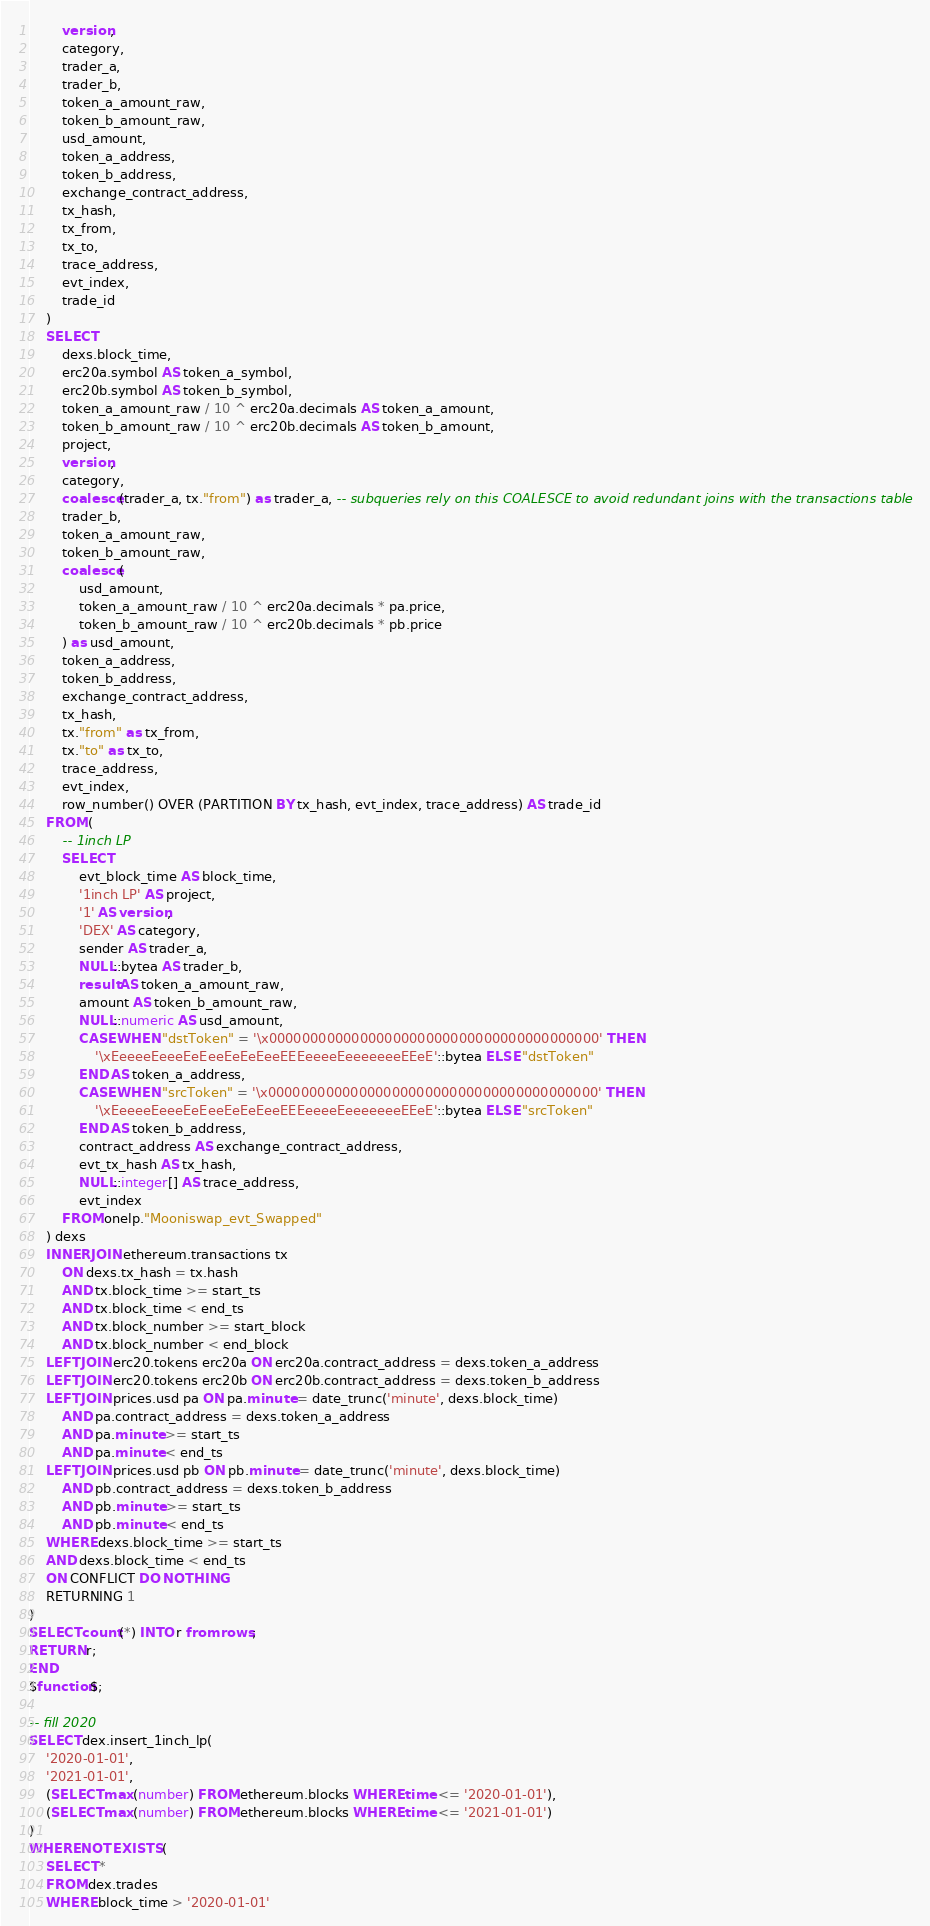<code> <loc_0><loc_0><loc_500><loc_500><_SQL_>        version,
        category,
        trader_a,
        trader_b,
        token_a_amount_raw,
        token_b_amount_raw,
        usd_amount,
        token_a_address,
        token_b_address,
        exchange_contract_address,
        tx_hash,
        tx_from,
        tx_to,
        trace_address,
        evt_index,
        trade_id
    )
    SELECT
        dexs.block_time,
        erc20a.symbol AS token_a_symbol,
        erc20b.symbol AS token_b_symbol,
        token_a_amount_raw / 10 ^ erc20a.decimals AS token_a_amount,
        token_b_amount_raw / 10 ^ erc20b.decimals AS token_b_amount,
        project,
        version,
        category,
        coalesce(trader_a, tx."from") as trader_a, -- subqueries rely on this COALESCE to avoid redundant joins with the transactions table
        trader_b,
        token_a_amount_raw,
        token_b_amount_raw,
        coalesce(
            usd_amount,
            token_a_amount_raw / 10 ^ erc20a.decimals * pa.price,
            token_b_amount_raw / 10 ^ erc20b.decimals * pb.price
        ) as usd_amount,
        token_a_address,
        token_b_address,
        exchange_contract_address,
        tx_hash,
        tx."from" as tx_from,
        tx."to" as tx_to,
        trace_address,
        evt_index,
        row_number() OVER (PARTITION BY tx_hash, evt_index, trace_address) AS trade_id
    FROM (
        -- 1inch LP
        SELECT
            evt_block_time AS block_time,
            '1inch LP' AS project,
            '1' AS version,
            'DEX' AS category,
            sender AS trader_a,
            NULL::bytea AS trader_b,
            result AS token_a_amount_raw,
            amount AS token_b_amount_raw,
            NULL::numeric AS usd_amount,
            CASE WHEN "dstToken" = '\x0000000000000000000000000000000000000000' THEN 
                '\xEeeeeEeeeEeEeeEeEeEeeEEEeeeeEeeeeeeeEEeE'::bytea ELSE "dstToken"
            END AS token_a_address,
            CASE WHEN "srcToken" = '\x0000000000000000000000000000000000000000' THEN 
                '\xEeeeeEeeeEeEeeEeEeEeeEEEeeeeEeeeeeeeEEeE'::bytea ELSE "srcToken"
            END AS token_b_address,
            contract_address AS exchange_contract_address,
            evt_tx_hash AS tx_hash,
            NULL::integer[] AS trace_address,
            evt_index
        FROM onelp."Mooniswap_evt_Swapped"
    ) dexs
    INNER JOIN ethereum.transactions tx
        ON dexs.tx_hash = tx.hash
        AND tx.block_time >= start_ts
        AND tx.block_time < end_ts
        AND tx.block_number >= start_block
        AND tx.block_number < end_block
    LEFT JOIN erc20.tokens erc20a ON erc20a.contract_address = dexs.token_a_address
    LEFT JOIN erc20.tokens erc20b ON erc20b.contract_address = dexs.token_b_address
    LEFT JOIN prices.usd pa ON pa.minute = date_trunc('minute', dexs.block_time)
        AND pa.contract_address = dexs.token_a_address
        AND pa.minute >= start_ts
        AND pa.minute < end_ts
    LEFT JOIN prices.usd pb ON pb.minute = date_trunc('minute', dexs.block_time)
        AND pb.contract_address = dexs.token_b_address
        AND pb.minute >= start_ts
        AND pb.minute < end_ts
    WHERE dexs.block_time >= start_ts
    AND dexs.block_time < end_ts
    ON CONFLICT DO NOTHING
    RETURNING 1
)
SELECT count(*) INTO r from rows;
RETURN r;
END
$function$;

-- fill 2020
SELECT dex.insert_1inch_lp(
    '2020-01-01',
    '2021-01-01',
    (SELECT max(number) FROM ethereum.blocks WHERE time <= '2020-01-01'),
    (SELECT max(number) FROM ethereum.blocks WHERE time <= '2021-01-01')
)
WHERE NOT EXISTS (
    SELECT *
    FROM dex.trades
    WHERE block_time > '2020-01-01'</code> 